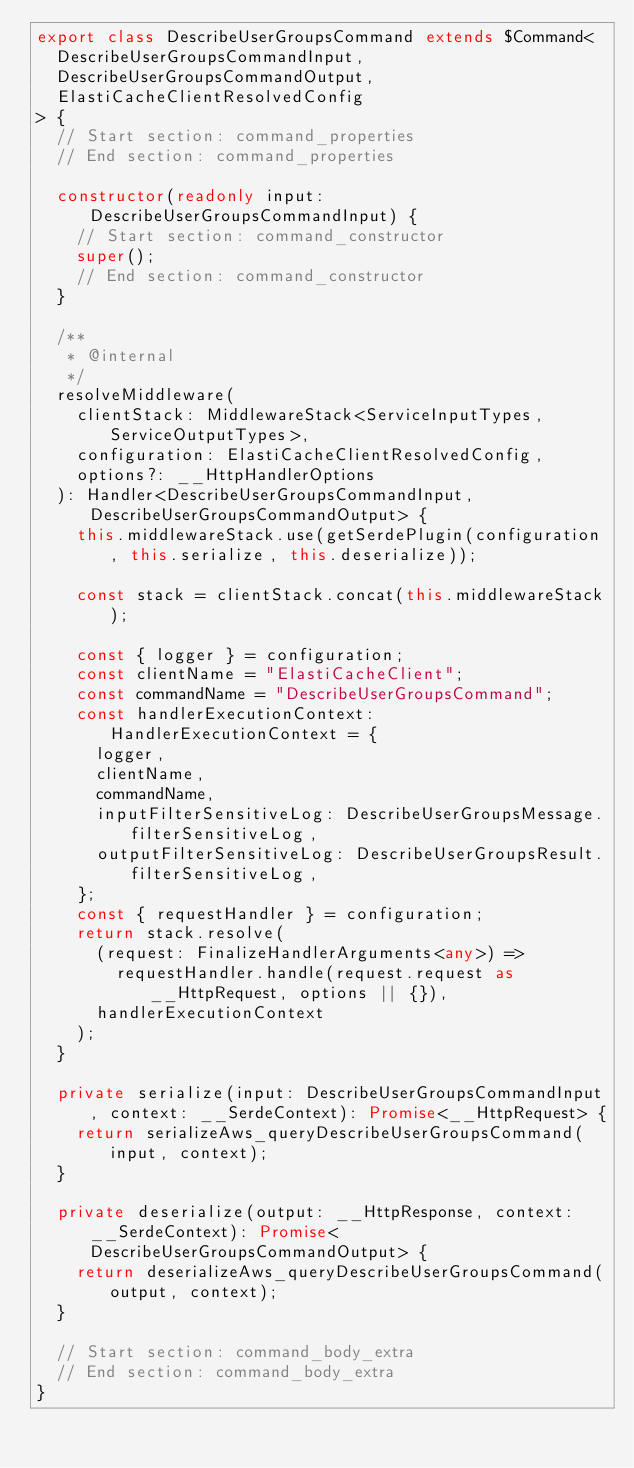<code> <loc_0><loc_0><loc_500><loc_500><_TypeScript_>export class DescribeUserGroupsCommand extends $Command<
  DescribeUserGroupsCommandInput,
  DescribeUserGroupsCommandOutput,
  ElastiCacheClientResolvedConfig
> {
  // Start section: command_properties
  // End section: command_properties

  constructor(readonly input: DescribeUserGroupsCommandInput) {
    // Start section: command_constructor
    super();
    // End section: command_constructor
  }

  /**
   * @internal
   */
  resolveMiddleware(
    clientStack: MiddlewareStack<ServiceInputTypes, ServiceOutputTypes>,
    configuration: ElastiCacheClientResolvedConfig,
    options?: __HttpHandlerOptions
  ): Handler<DescribeUserGroupsCommandInput, DescribeUserGroupsCommandOutput> {
    this.middlewareStack.use(getSerdePlugin(configuration, this.serialize, this.deserialize));

    const stack = clientStack.concat(this.middlewareStack);

    const { logger } = configuration;
    const clientName = "ElastiCacheClient";
    const commandName = "DescribeUserGroupsCommand";
    const handlerExecutionContext: HandlerExecutionContext = {
      logger,
      clientName,
      commandName,
      inputFilterSensitiveLog: DescribeUserGroupsMessage.filterSensitiveLog,
      outputFilterSensitiveLog: DescribeUserGroupsResult.filterSensitiveLog,
    };
    const { requestHandler } = configuration;
    return stack.resolve(
      (request: FinalizeHandlerArguments<any>) =>
        requestHandler.handle(request.request as __HttpRequest, options || {}),
      handlerExecutionContext
    );
  }

  private serialize(input: DescribeUserGroupsCommandInput, context: __SerdeContext): Promise<__HttpRequest> {
    return serializeAws_queryDescribeUserGroupsCommand(input, context);
  }

  private deserialize(output: __HttpResponse, context: __SerdeContext): Promise<DescribeUserGroupsCommandOutput> {
    return deserializeAws_queryDescribeUserGroupsCommand(output, context);
  }

  // Start section: command_body_extra
  // End section: command_body_extra
}
</code> 